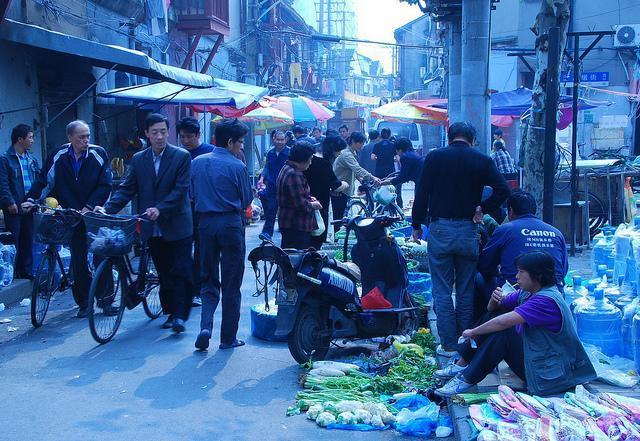How many bicycles are visible in this picture?
Give a very brief answer. 3. How many bicycles are in the photo?
Give a very brief answer. 2. How many people are in the picture?
Give a very brief answer. 9. How many chairs are behind the pole?
Give a very brief answer. 0. 